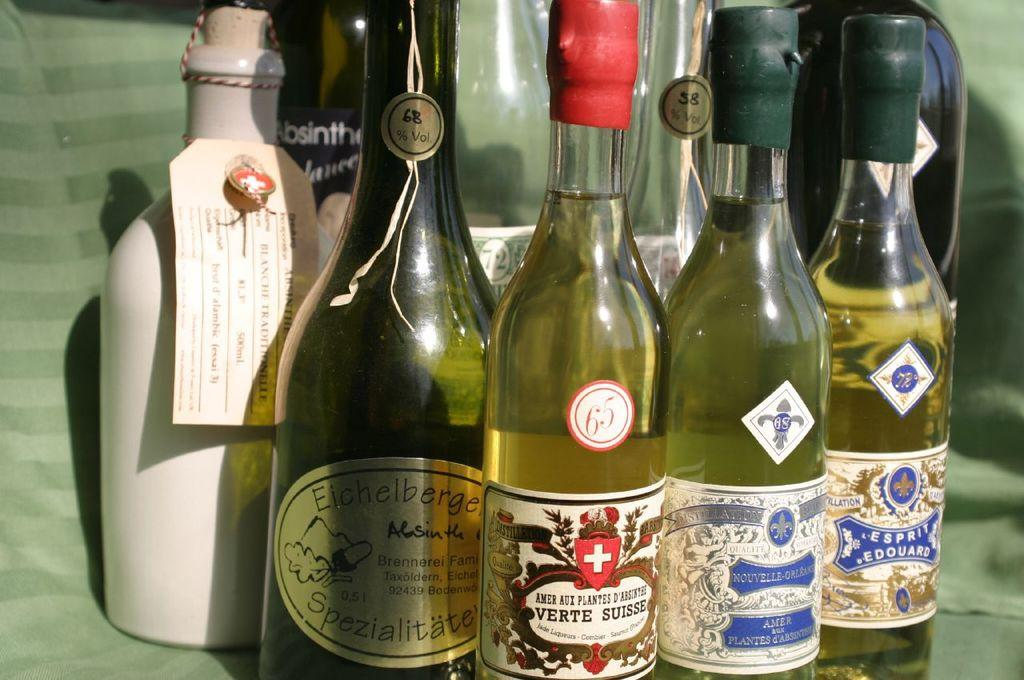<image>
Provide a brief description of the given image. Several bottles bundled close together, including Verte Suisse. 